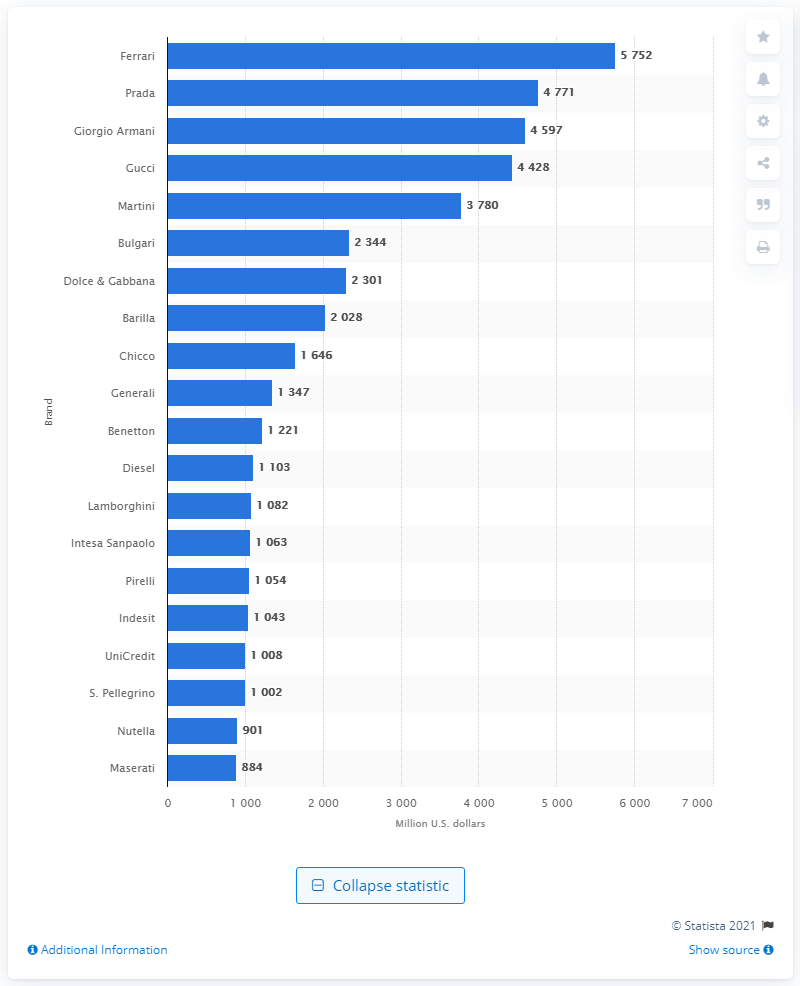Mention a couple of crucial points in this snapshot. In 2012, Ferrari was the top-ranked Italian brand with an estimated brand value of approximately 5.75 billion U.S. dollars. Giorgio Armani was the third most valuable Italian brand in 2012. 